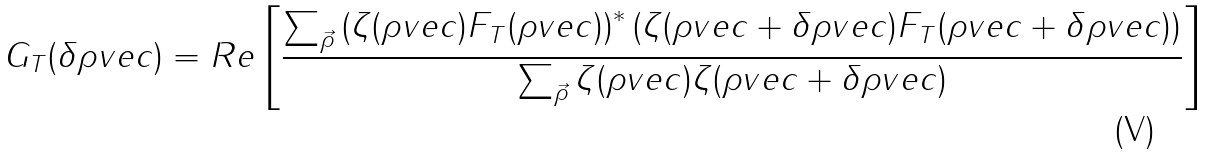Convert formula to latex. <formula><loc_0><loc_0><loc_500><loc_500>G _ { T } ( \delta \rho v e c ) = R e \left [ \frac { \sum _ { \vec { \rho } } \left ( \zeta ( \rho v e c ) F _ { T } ( \rho v e c ) \right ) ^ { * } \left ( \zeta ( \rho v e c + \delta \rho v e c ) F _ { T } ( \rho v e c + \delta \rho v e c ) \right ) } { \sum _ { \vec { \rho } } \zeta ( \rho v e c ) \zeta ( \rho v e c + \delta \rho v e c ) } \right ]</formula> 